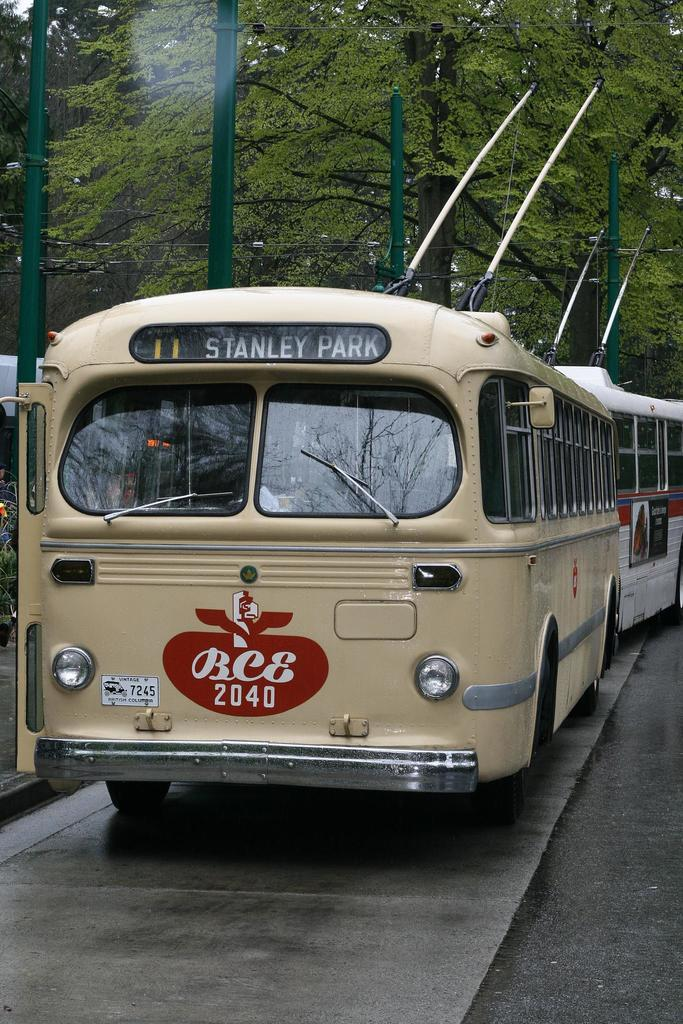What is the main subject in the center of the image? There are buses in the center of the image. What can be seen in the background of the image? There are trees and poles with wires in the background of the image. What is at the bottom of the image? There is a road at the bottom of the image. Where is the desk located in the image? There is no desk present in the image. What type of education is being taught in the image? There is no indication of education or teaching in the image. 